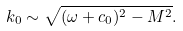<formula> <loc_0><loc_0><loc_500><loc_500>k _ { 0 } \sim \sqrt { ( \omega + c _ { 0 } ) ^ { 2 } - M ^ { 2 } } .</formula> 